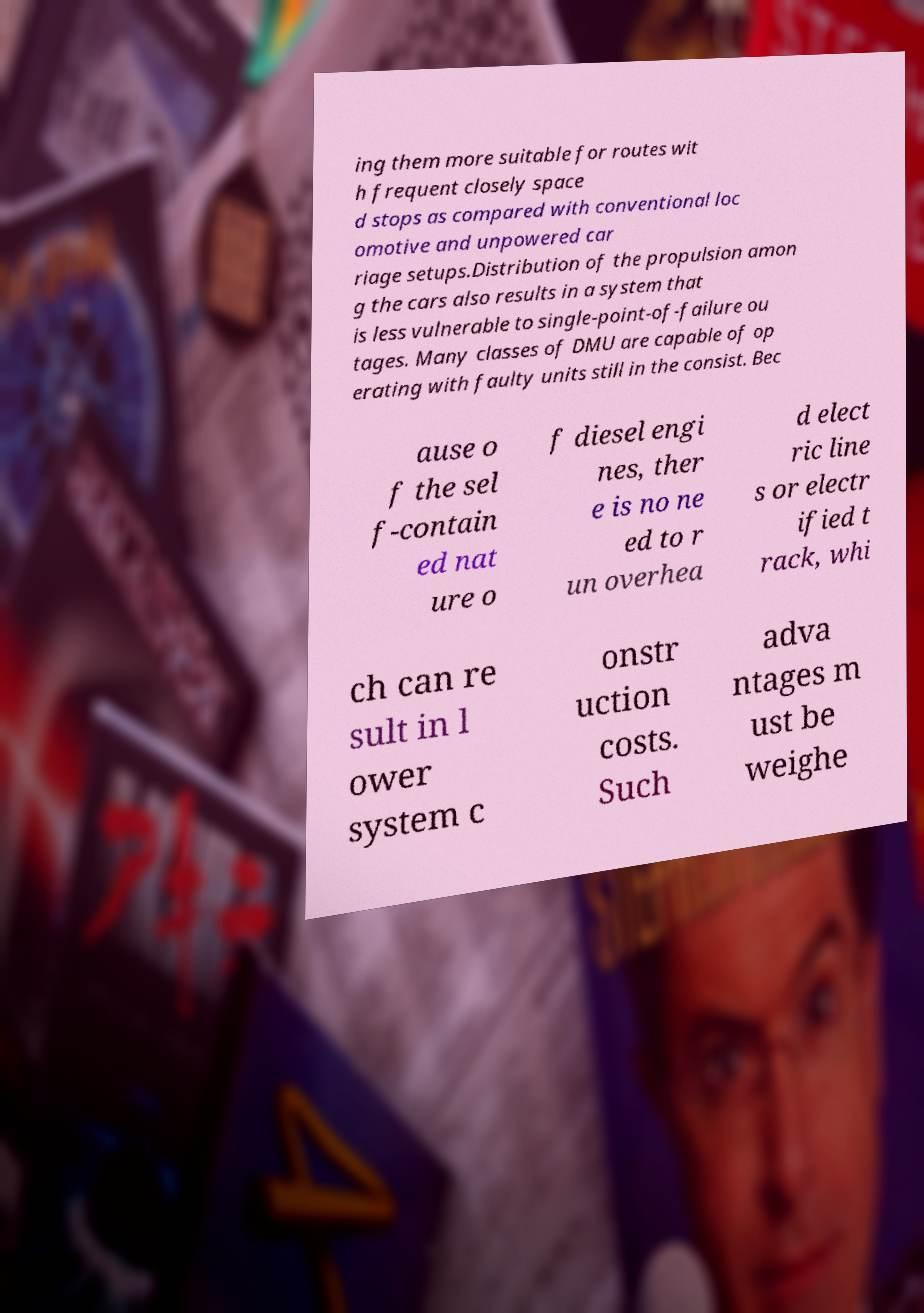Could you extract and type out the text from this image? ing them more suitable for routes wit h frequent closely space d stops as compared with conventional loc omotive and unpowered car riage setups.Distribution of the propulsion amon g the cars also results in a system that is less vulnerable to single-point-of-failure ou tages. Many classes of DMU are capable of op erating with faulty units still in the consist. Bec ause o f the sel f-contain ed nat ure o f diesel engi nes, ther e is no ne ed to r un overhea d elect ric line s or electr ified t rack, whi ch can re sult in l ower system c onstr uction costs. Such adva ntages m ust be weighe 